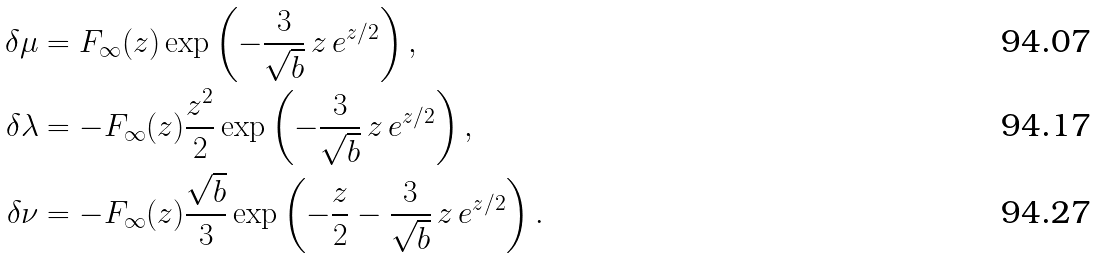Convert formula to latex. <formula><loc_0><loc_0><loc_500><loc_500>\delta \mu & = F _ { \infty } ( z ) \exp \left ( - \frac { 3 } { \sqrt { b } } \, z \, e ^ { z / 2 } \right ) , \\ \delta \lambda & = - F _ { \infty } ( z ) \frac { z ^ { 2 } } { 2 } \exp \left ( - \frac { 3 } { \sqrt { b } } \, z \, e ^ { z / 2 } \right ) , \\ \delta \nu & = - F _ { \infty } ( z ) \frac { \sqrt { b } } { 3 } \exp \left ( - \frac { z } { 2 } - \frac { 3 } { \sqrt { b } } \, z \, e ^ { z / 2 } \right ) .</formula> 